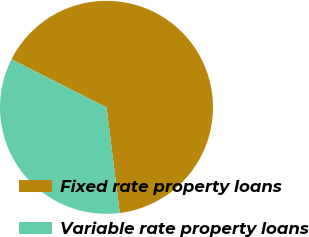Convert chart. <chart><loc_0><loc_0><loc_500><loc_500><pie_chart><fcel>Fixed rate property loans<fcel>Variable rate property loans<nl><fcel>65.57%<fcel>34.43%<nl></chart> 